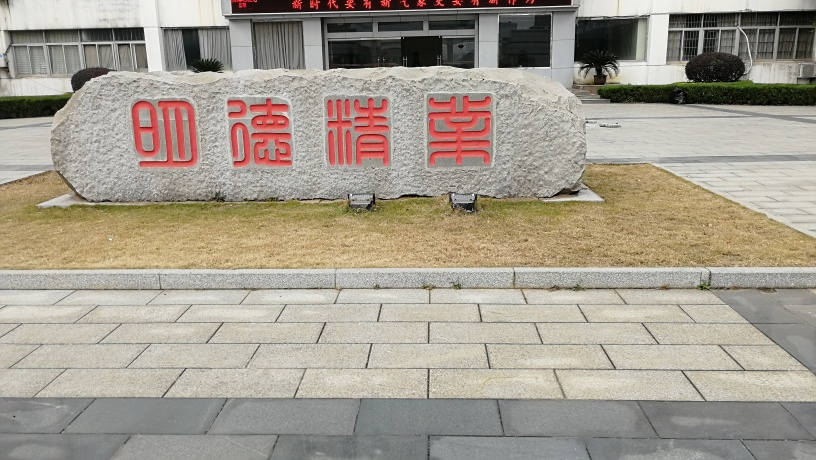What is the weather like when this photo was taken? The weather appears to be clear and sunny. There are no visible clouds in the sky, and the strong lighting and the nature of the shadows indicate that it is likely a fair-weather day. 